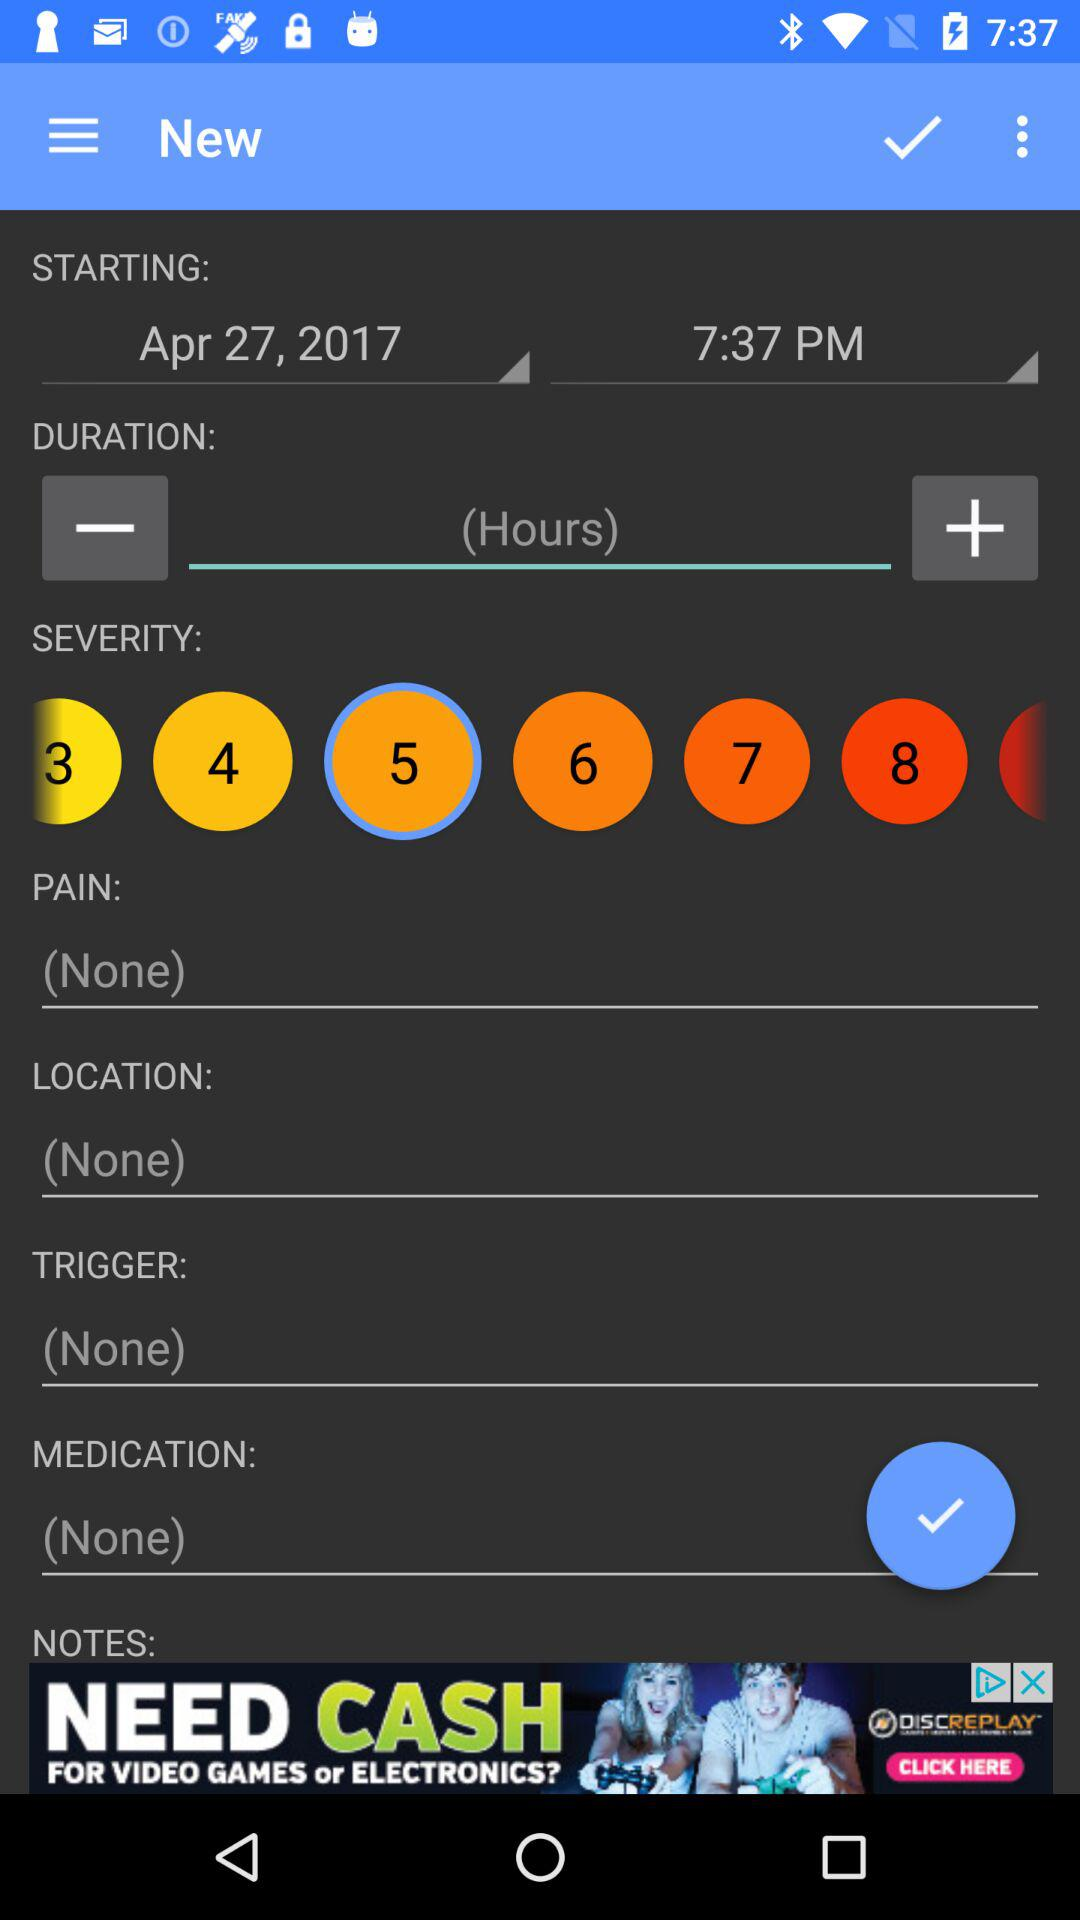How many hours is the duration?
When the provided information is insufficient, respond with <no answer>. <no answer> 